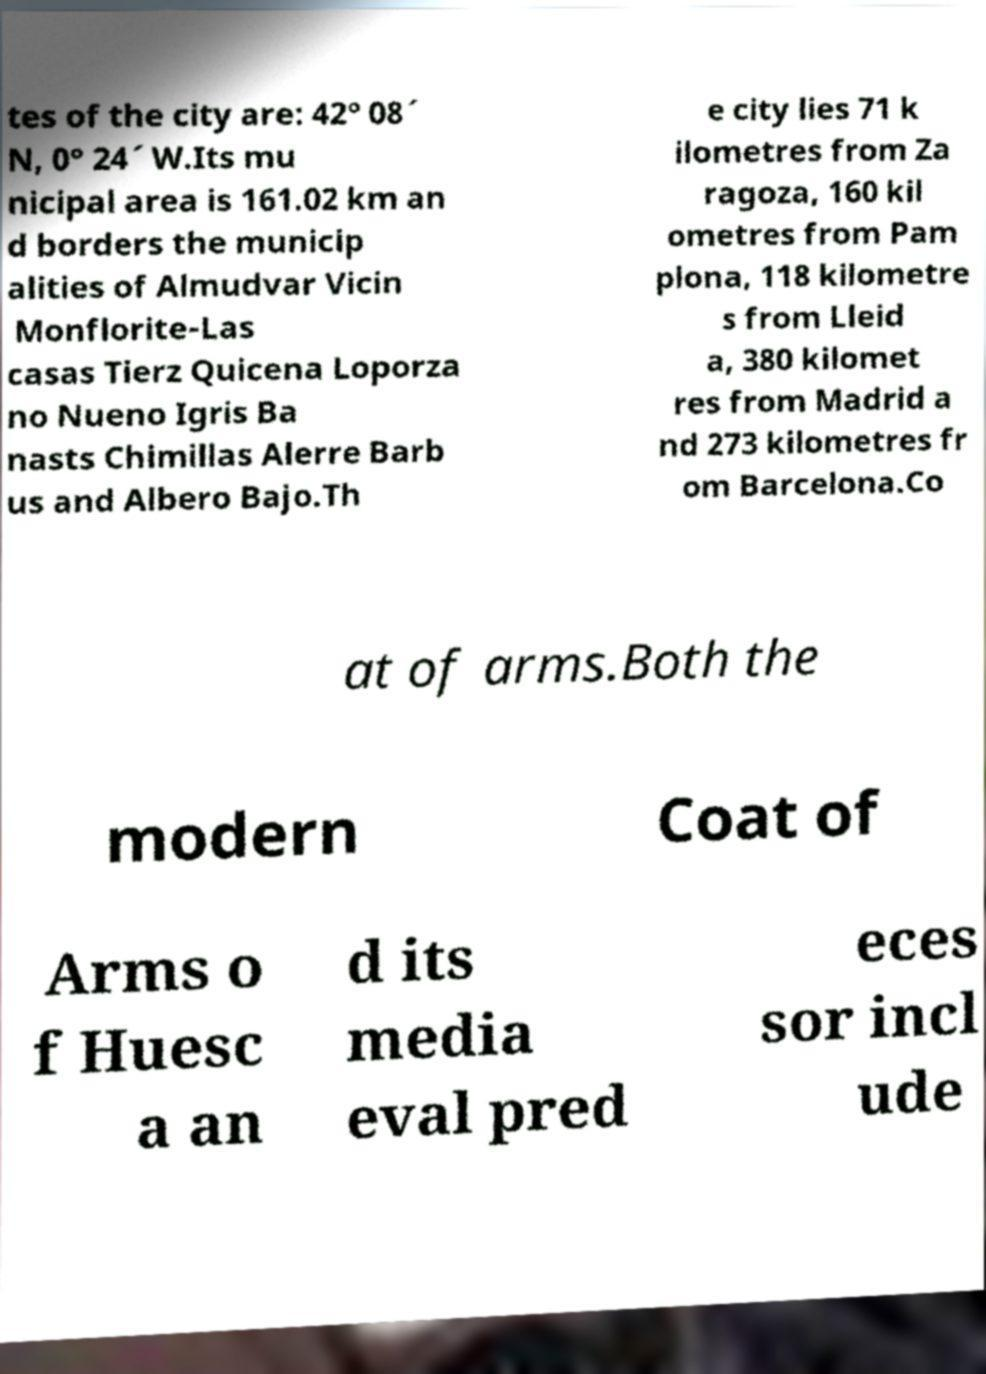There's text embedded in this image that I need extracted. Can you transcribe it verbatim? tes of the city are: 42° 08´ N, 0° 24´ W.Its mu nicipal area is 161.02 km an d borders the municip alities of Almudvar Vicin Monflorite-Las casas Tierz Quicena Loporza no Nueno Igris Ba nasts Chimillas Alerre Barb us and Albero Bajo.Th e city lies 71 k ilometres from Za ragoza, 160 kil ometres from Pam plona, 118 kilometre s from Lleid a, 380 kilomet res from Madrid a nd 273 kilometres fr om Barcelona.Co at of arms.Both the modern Coat of Arms o f Huesc a an d its media eval pred eces sor incl ude 